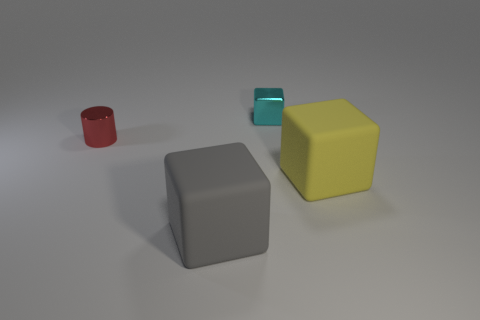Subtract all big gray blocks. How many blocks are left? 2 Subtract 3 blocks. How many blocks are left? 0 Add 2 large blue shiny balls. How many objects exist? 6 Subtract all cyan blocks. How many green cylinders are left? 0 Subtract all small cyan objects. Subtract all tiny gray spheres. How many objects are left? 3 Add 3 big yellow matte blocks. How many big yellow matte blocks are left? 4 Add 1 small red cylinders. How many small red cylinders exist? 2 Subtract 1 cyan blocks. How many objects are left? 3 Subtract all cubes. How many objects are left? 1 Subtract all blue blocks. Subtract all blue cylinders. How many blocks are left? 3 